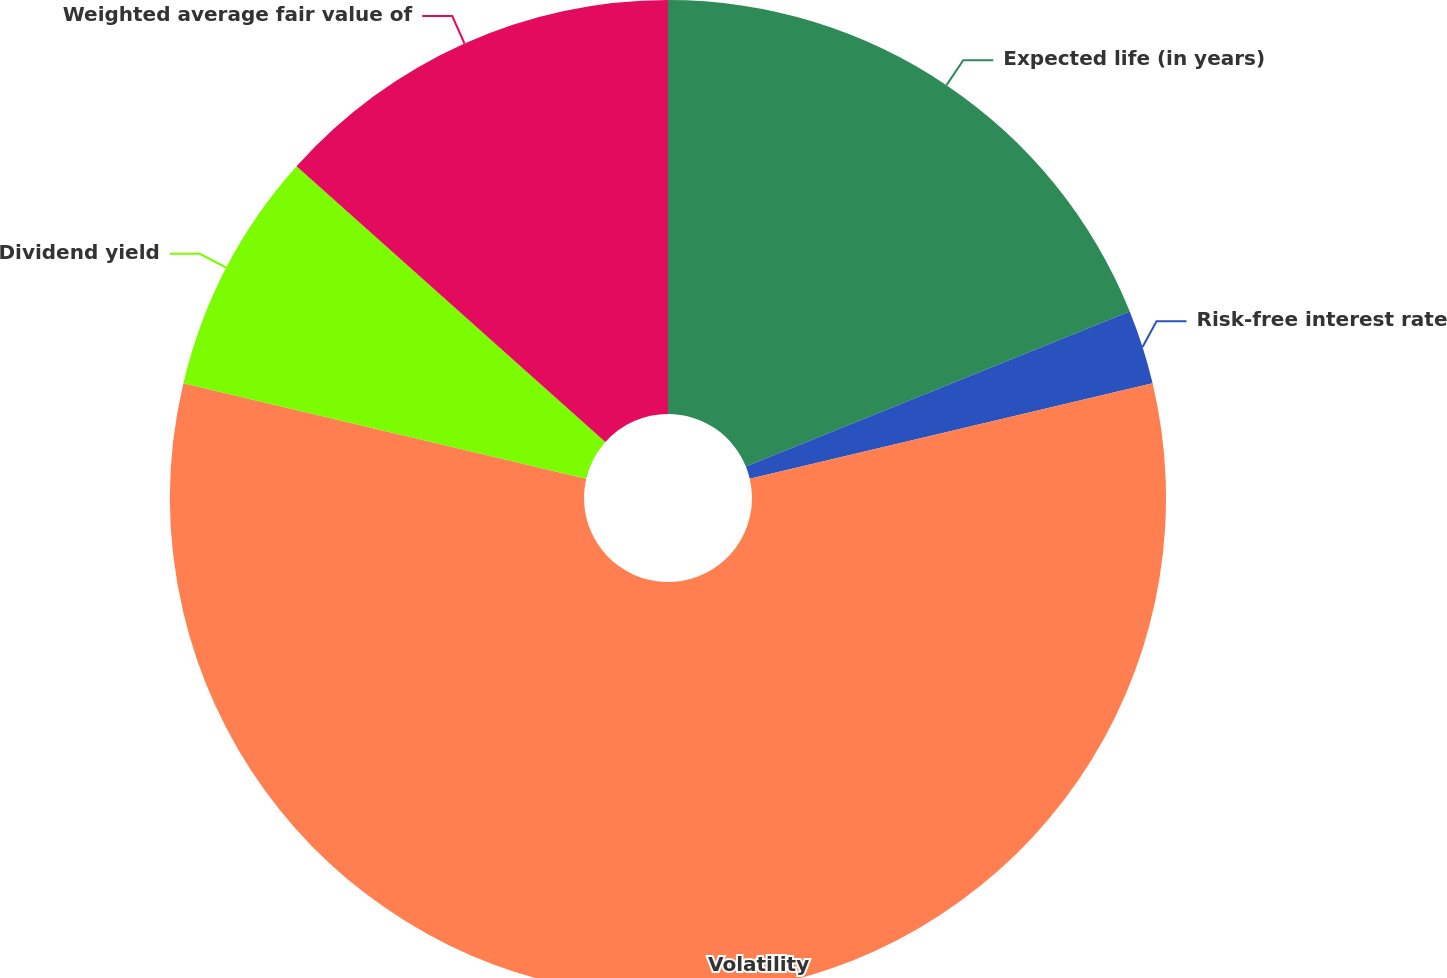Convert chart to OTSL. <chart><loc_0><loc_0><loc_500><loc_500><pie_chart><fcel>Expected life (in years)<fcel>Risk-free interest rate<fcel>Volatility<fcel>Dividend yield<fcel>Weighted average fair value of<nl><fcel>18.89%<fcel>2.41%<fcel>57.4%<fcel>7.9%<fcel>13.4%<nl></chart> 